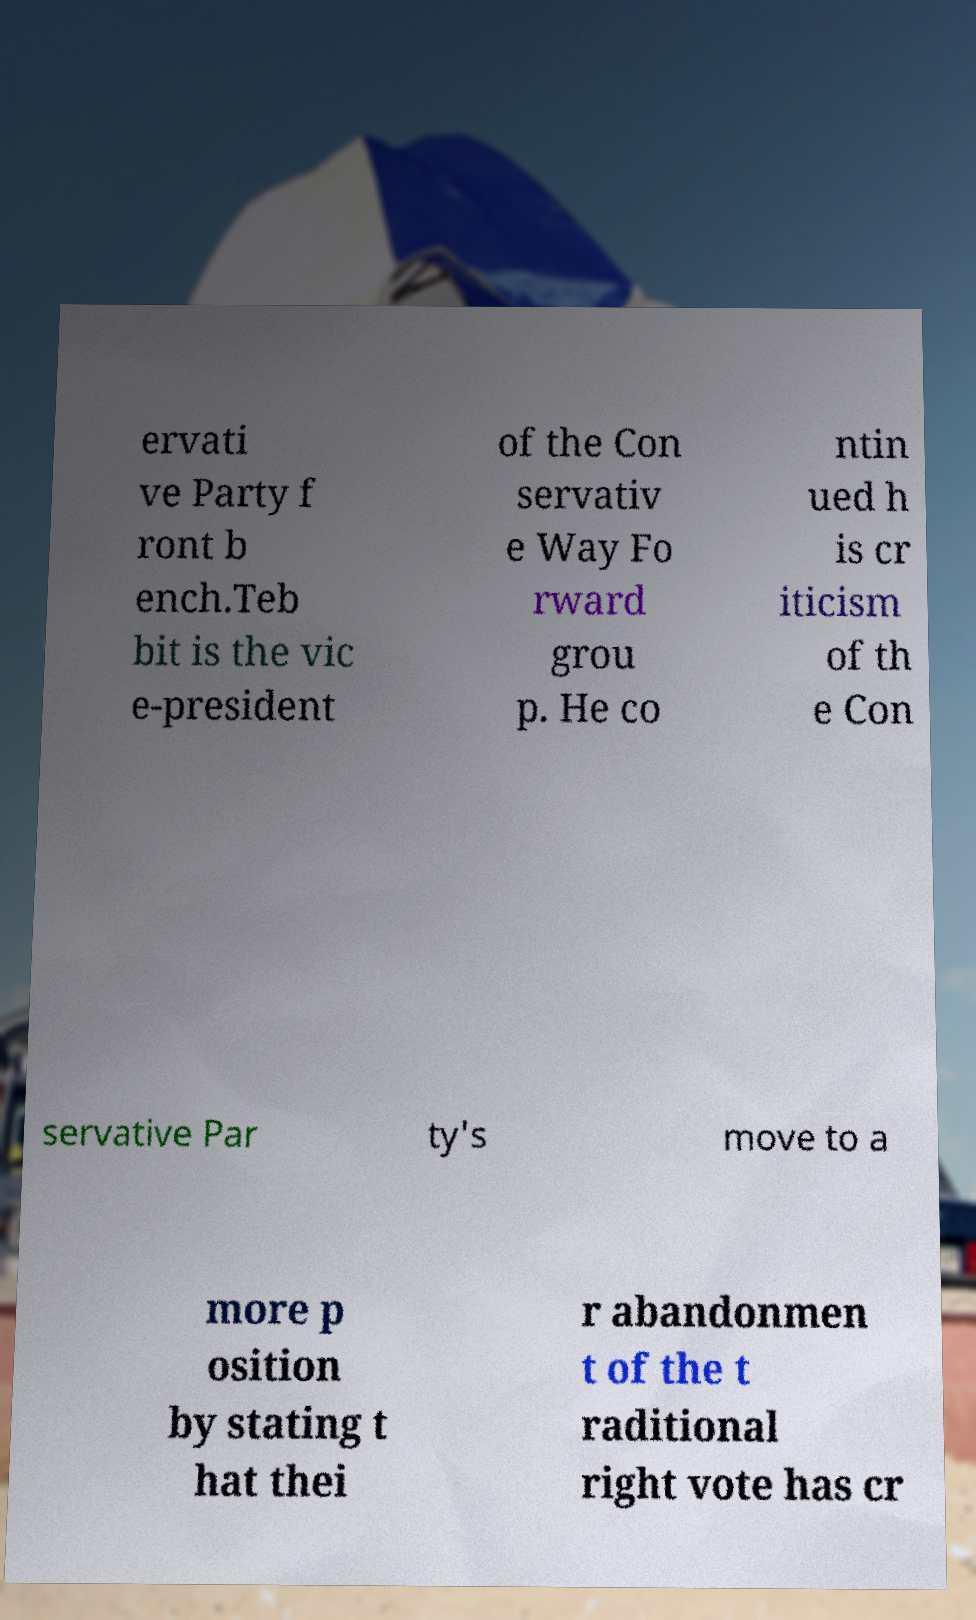Can you read and provide the text displayed in the image?This photo seems to have some interesting text. Can you extract and type it out for me? ervati ve Party f ront b ench.Teb bit is the vic e-president of the Con servativ e Way Fo rward grou p. He co ntin ued h is cr iticism of th e Con servative Par ty's move to a more p osition by stating t hat thei r abandonmen t of the t raditional right vote has cr 